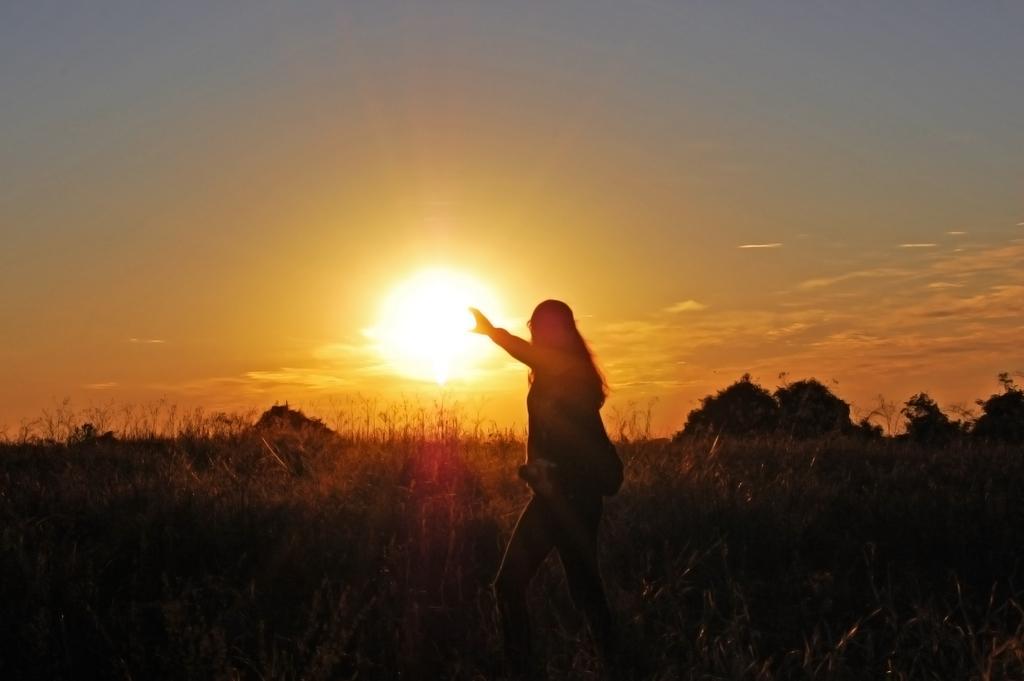What is the main subject in the image? There is a woman standing in the image. What can be seen under the woman's feet? The ground is visible in the image. What type of surface is the ground covered with? The ground is covered with grass. What is happening in the sky in the image? There is a sunset in the sky. How many babies are crawling on the powder in the image? There is no powder or babies present in the image. 